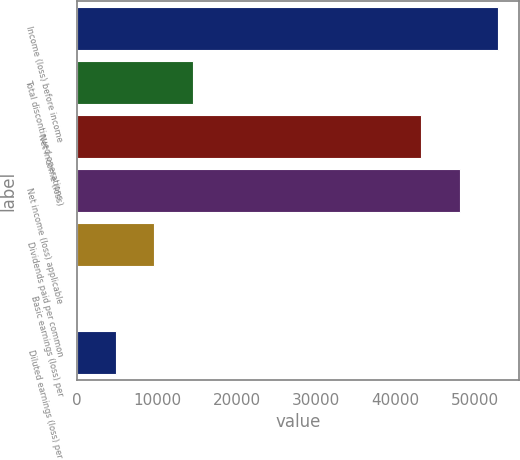Convert chart to OTSL. <chart><loc_0><loc_0><loc_500><loc_500><bar_chart><fcel>Income (loss) before income<fcel>Total discontinued operations<fcel>Net income (loss)<fcel>Net income (loss) applicable<fcel>Dividends paid per common<fcel>Basic earnings (loss) per<fcel>Diluted earnings (loss) per<nl><fcel>52883.4<fcel>14495.2<fcel>43220<fcel>48051.7<fcel>9663.54<fcel>0.18<fcel>4831.86<nl></chart> 